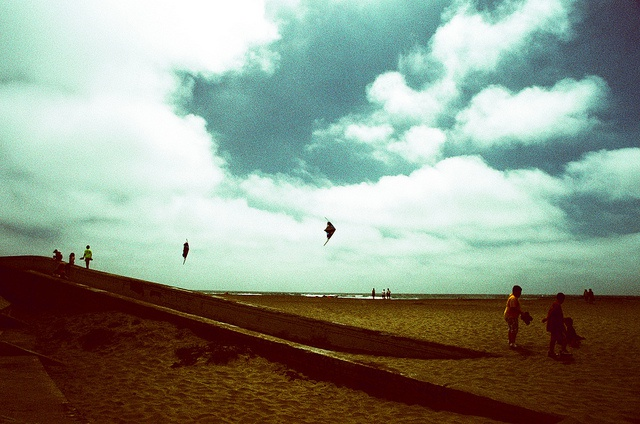Describe the objects in this image and their specific colors. I can see people in turquoise, black, maroon, and gray tones, people in turquoise, maroon, brown, and olive tones, people in turquoise, maroon, and brown tones, people in maroon, turquoise, and black tones, and people in turquoise, black, olive, maroon, and gray tones in this image. 